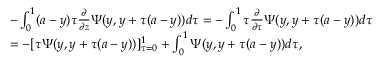Convert formula to latex. <formula><loc_0><loc_0><loc_500><loc_500>\begin{array} { r l } & { - \int _ { 0 } ^ { 1 } ( a - y ) \tau \frac { \partial } { \partial z } \Psi ( y , y + \tau ( a - y ) ) d \tau = - \int _ { 0 } ^ { 1 } \tau \frac { \partial } { \partial \tau } \Psi ( y , y + \tau ( a - y ) ) d \tau } \\ & { = - [ \tau \Psi ( y , y + \tau ( a - y ) ) ] _ { \tau = 0 } ^ { 1 } + \int _ { 0 } ^ { 1 } \Psi ( y , y + \tau ( a - y ) ) d \tau , } \end{array}</formula> 